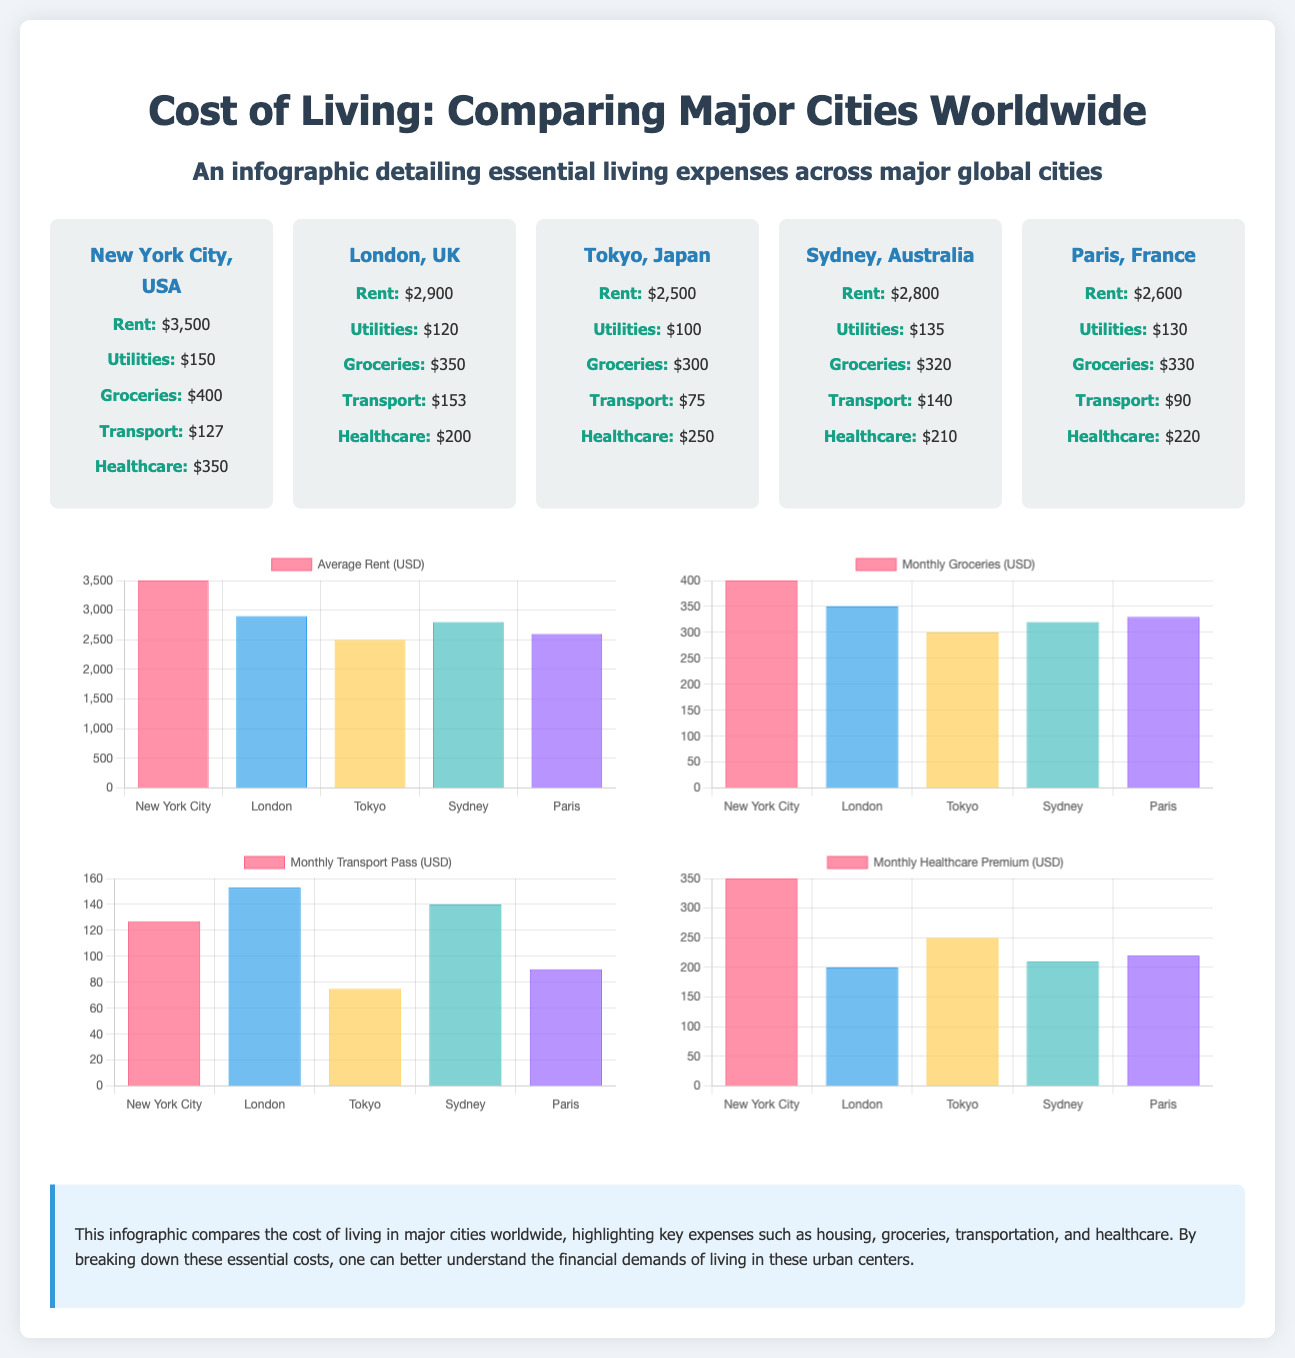What is the highest rent among the cities? The highest rent is listed in the New York City section of the infographic, which shows $3,500.
Answer: $3,500 Which city has the lowest transportation cost? The city with the lowest transportation cost is Tokyo, which has a monthly transport cost of $75.
Answer: $75 What is the monthly grocery expenditure in Sydney? The monthly grocery expenditure in Sydney is shown as $320.
Answer: $320 Which city has the highest healthcare expense? According to the infographic, New York City has the highest healthcare expense at $350.
Answer: $350 What is the total healthcare cost across all cities? The total healthcare cost is calculated by adding the individual healthcare expenses of all cities, totaling to $1,600.
Answer: $1,600 How much more does it cost to rent in London compared to Tokyo? The rent in London is $2,900 and in Tokyo is $2,500, which makes the difference $400.
Answer: $400 Which city has the highest utilities cost? The city with the highest utilities cost is Sydney at $135.
Answer: $135 What is the average rent across all cities? The average rent is calculated by summing the rents of all cities and dividing by the number of cities, resulting in an average of $2,680.
Answer: $2,680 What type of chart is used for monthly transportation costs? The chart for monthly transportation costs is a bar chart, as indicated in the document.
Answer: Bar Chart 